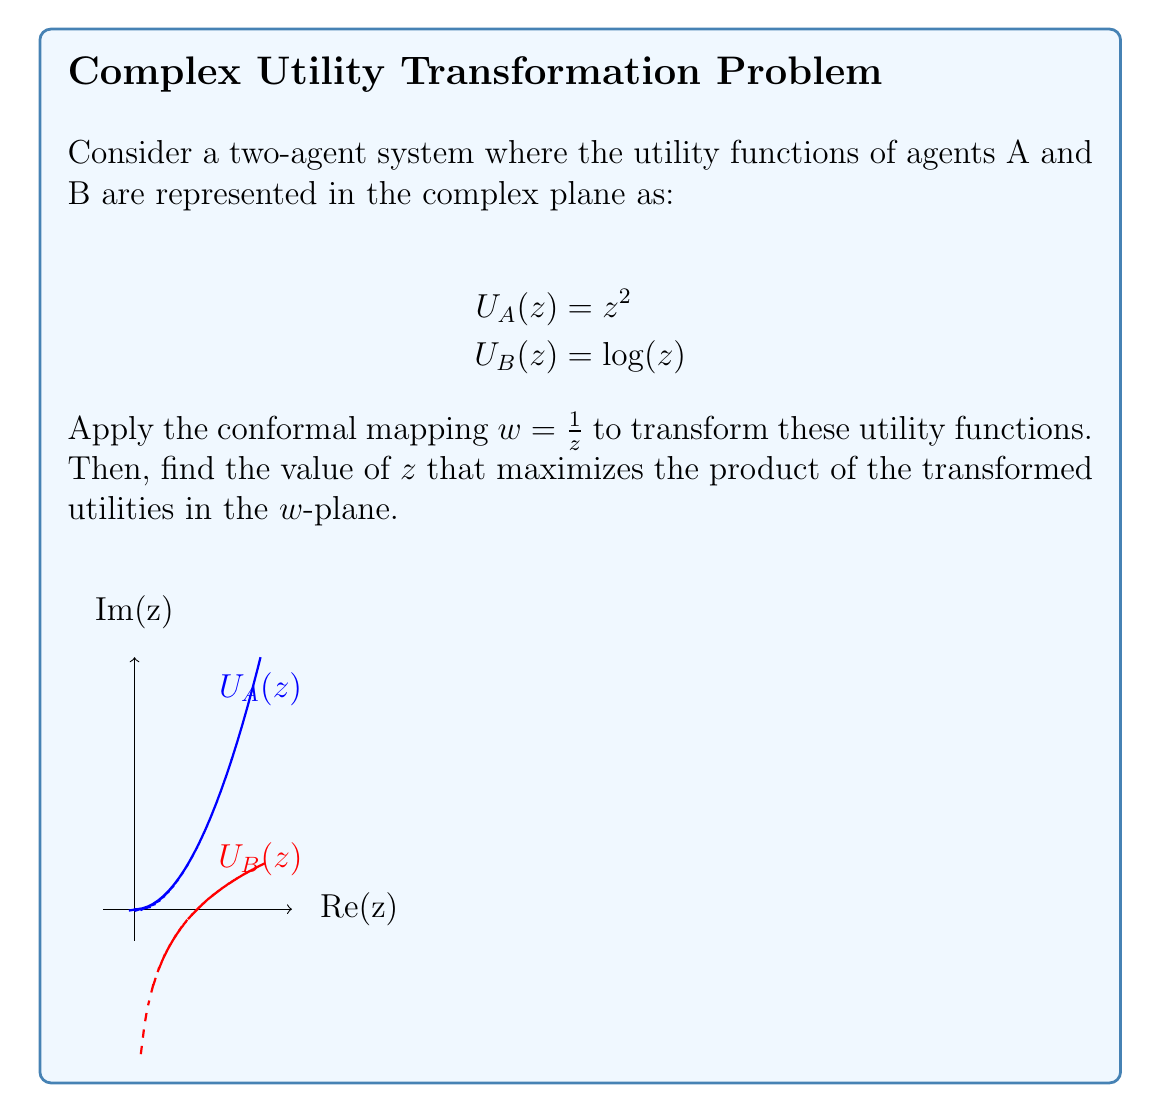Provide a solution to this math problem. Let's approach this step-by-step:

1) First, we apply the conformal mapping $w = \frac{1}{z}$ to both utility functions.

   For $U_A(z) = z^2$:
   $$U_A(w) = (\frac{1}{w})^2 = \frac{1}{w^2}$$

   For $U_B(z) = \log(z)$:
   $$U_B(w) = \log(\frac{1}{w}) = -\log(w)$$

2) Now, we want to maximize the product of these transformed utilities:

   $$\max_{w} \left(\frac{1}{w^2} \cdot (-\log(w))\right)$$

3) Let's call this product $P(w)$:

   $$P(w) = -\frac{\log(w)}{w^2}$$

4) To find the maximum, we differentiate $P(w)$ and set it to zero:

   $$\frac{d}{dw}P(w) = -\frac{1}{w^3} + \frac{2\log(w)}{w^3} = 0$$

5) Solving this equation:

   $$-1 + 2\log(w) = 0$$
   $$2\log(w) = 1$$
   $$\log(w) = \frac{1}{2}$$
   $$w = e^{\frac{1}{2}}$$

6) To get back to the original $z$-plane, we use the inverse of our conformal mapping:

   $$z = \frac{1}{w} = \frac{1}{e^{\frac{1}{2}}} = e^{-\frac{1}{2}}$$

Therefore, the value of $z$ that maximizes the product of the transformed utilities in the $w$-plane is $e^{-\frac{1}{2}}$.
Answer: $e^{-\frac{1}{2}}$ 